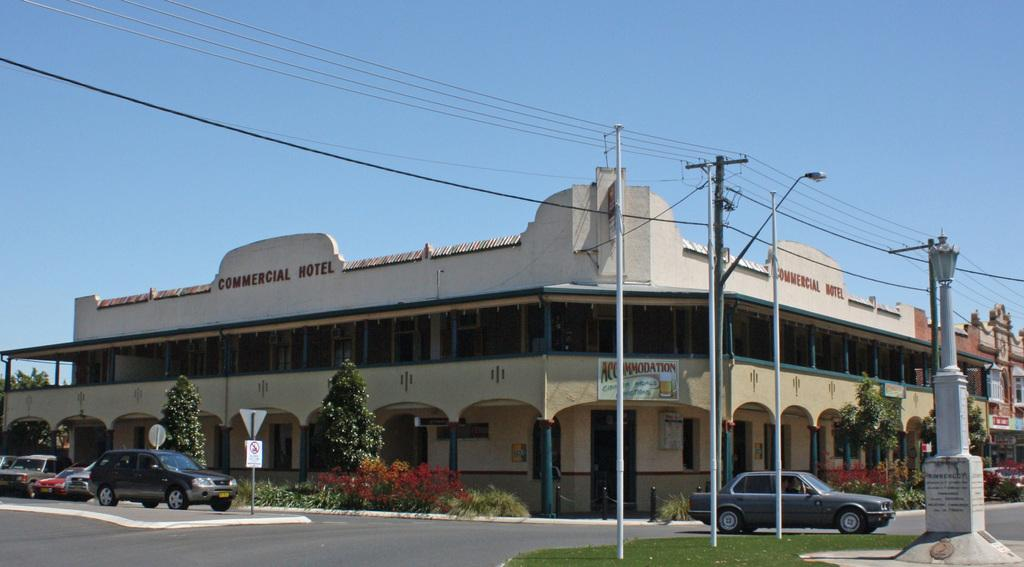What types of objects are in the image? There are vehicles and trees in the image. What small animals can be seen at the bottom of the image? There are moles present at the bottom of the image. What structure is visible in the background of the image? There is a building in the background of the image. What is visible at the top of the image? The sky is visible at the top of the image. Can you tell me how many donkeys are standing next to the building in the image? There are no donkeys present in the image; it features vehicles, trees, moles, and a building. What thought is being expressed by the moles in the image? There is no indication of any thoughts being expressed by the moles in the image, as they are small animals and do not have the ability to express thoughts. 